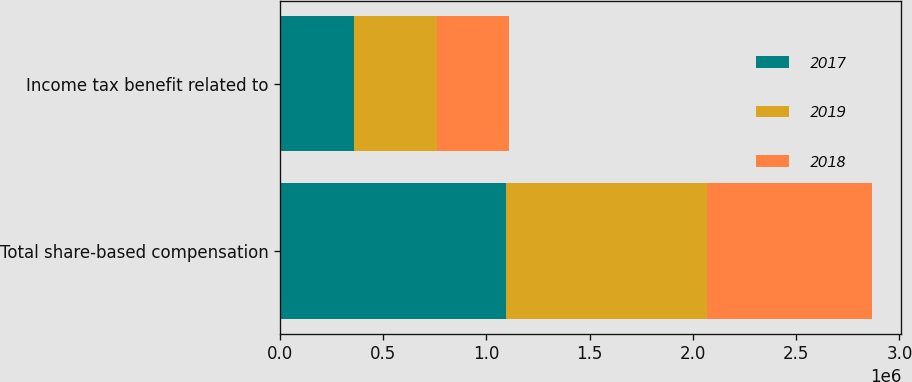Convert chart. <chart><loc_0><loc_0><loc_500><loc_500><stacked_bar_chart><ecel><fcel>Total share-based compensation<fcel>Income tax benefit related to<nl><fcel>2017<fcel>1.09325e+06<fcel>356062<nl><fcel>2019<fcel>976908<fcel>404124<nl><fcel>2018<fcel>795235<fcel>349114<nl></chart> 